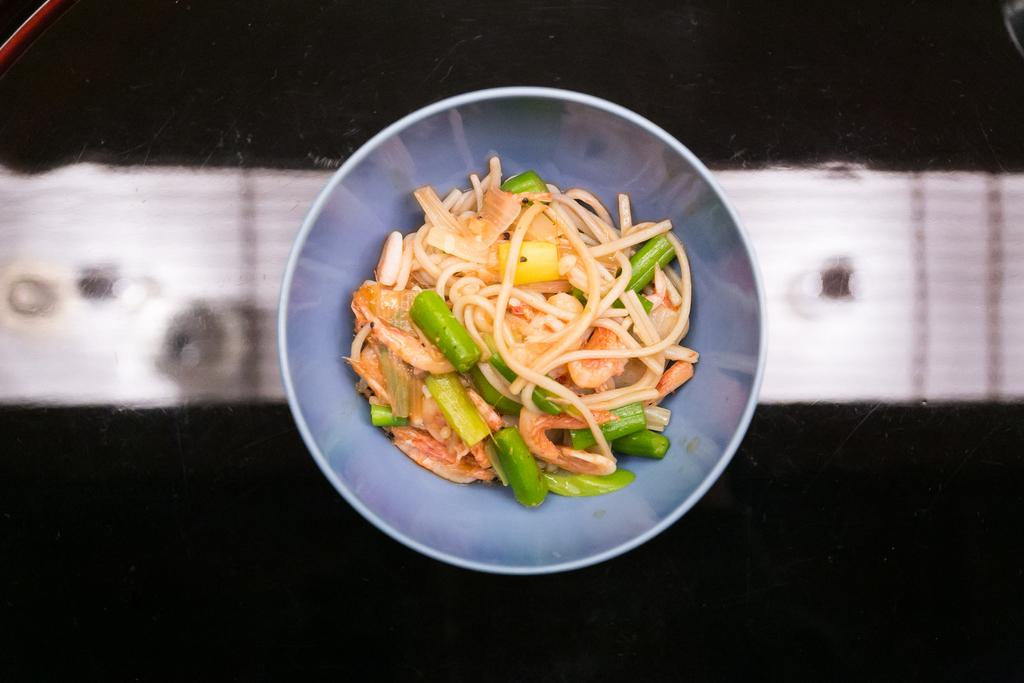What is in the bowl that is visible in the image? There is a bowl of noodles in the image. What color is the bowl? The bowl is blue. Where is the bowl located in the image? The bowl is on a surface. What does the bowl's dad say about the noodles in the image? There is no mention of a dad or any person in the image, so it is not possible to answer that question. 